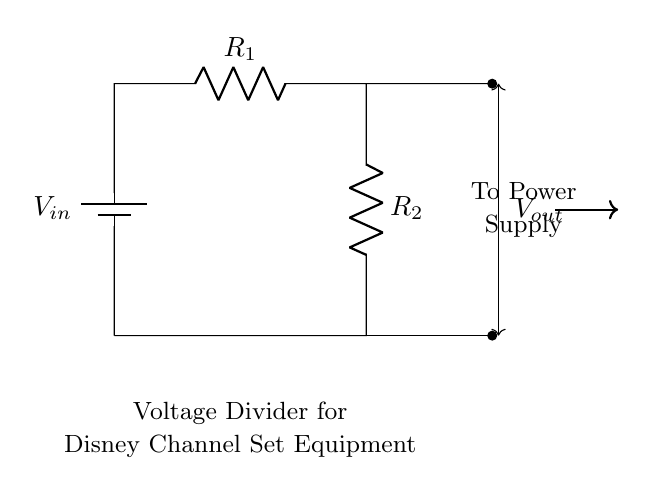What is the purpose of the voltage divider in this circuit? The voltage divider regulates the output voltage for the equipment. It takes a higher voltage input and produces a lower, precise output voltage.
Answer: Regulate voltage What are the two resistors in the circuit? The two resistors are R1 and R2, and they form the main components of the voltage divider. Their resistance values determine the output voltage.
Answer: R1 and R2 What is the output voltage labeled in the circuit? The output voltage is labeled as Vout, which represents the voltage that is taken from the voltage divider for use in the equipment.
Answer: Vout How many nodes are present in this circuit? The circuit has three nodes: the positive terminal of the battery, the connection between R1 and R2, and the ground connection. These nodes are where the components connect.
Answer: Three What happens to the output voltage if R1 is increased? Increasing R1 will raise the output voltage Vout because it will alter the voltage division ratio according to the formula Vout = Vin * (R2 / (R1 + R2)).
Answer: Increases Vout What is the relationship between R1 and R2 for desired Vout? For a desired output voltage, the relationship can be described by the voltage divider formula, which indicates that Vout is proportional to the ratio of R2 to the total resistance (R1 + R2).
Answer: R2/(R1+R2) Where does the power supply connect in this circuit? The power supply connects to the positive terminal of the battery labeled Vin, providing the necessary input voltage for the operation of the divider.
Answer: Vin 